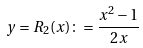Convert formula to latex. <formula><loc_0><loc_0><loc_500><loc_500>y = R _ { 2 } ( x ) \colon = \frac { x ^ { 2 } - 1 } { 2 x }</formula> 